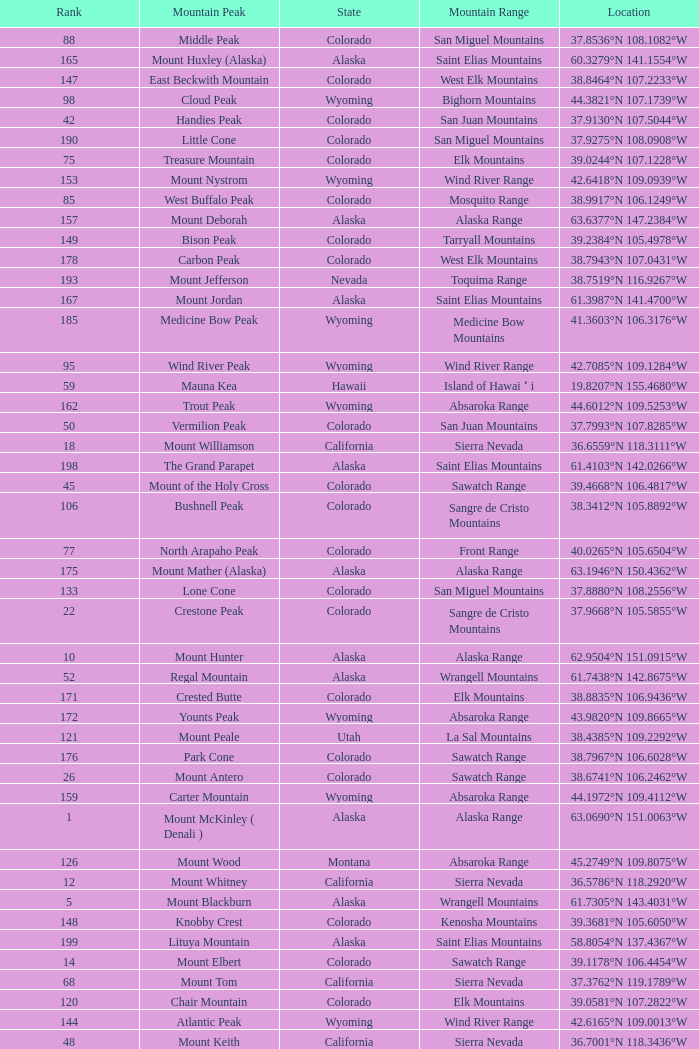What is the mountain peak when the location is 37.5775°n 105.4856°w? Blanca Peak. 